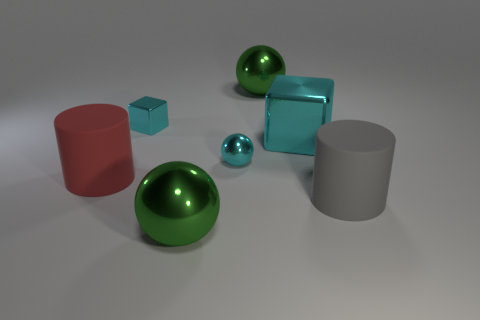Can you tell me about the lighting in the image and how it affects the mood? The lighting in the image is soft and diffused, casting gentle shadows that emphasize the shapes of the objects without creating harsh contrasts. It gives the scene a calm and tranquil atmosphere, which is soothing to the viewer. The overall mood is one of serenity, enhanced by the matte finish of the surfaces and the reflective quality of the spheres. 